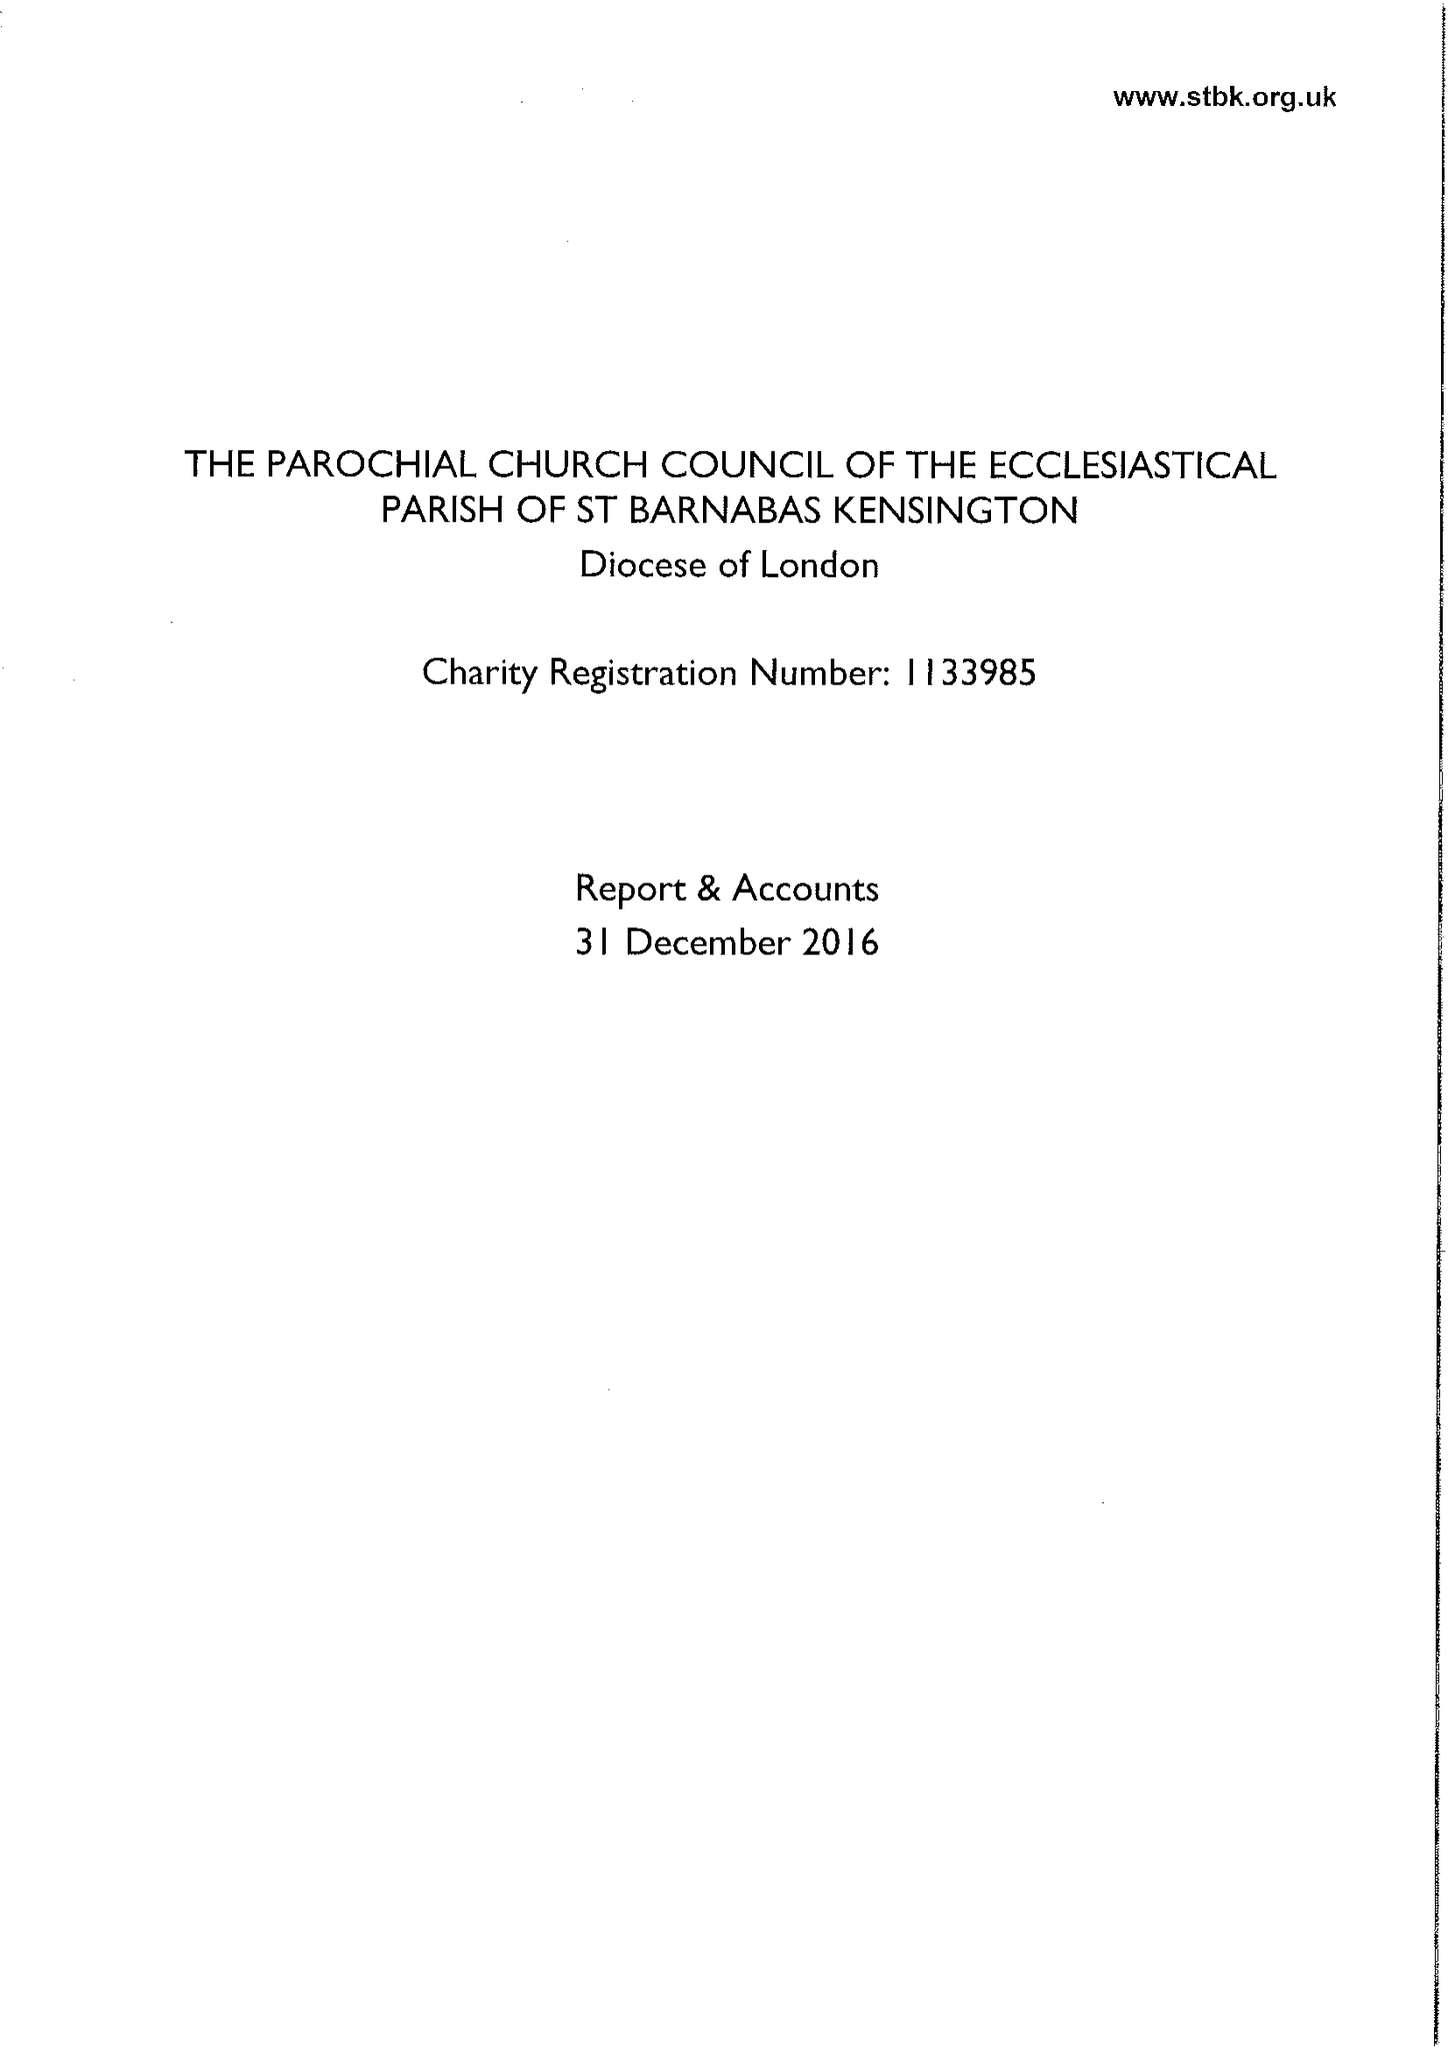What is the value for the spending_annually_in_british_pounds?
Answer the question using a single word or phrase. 464346.00 